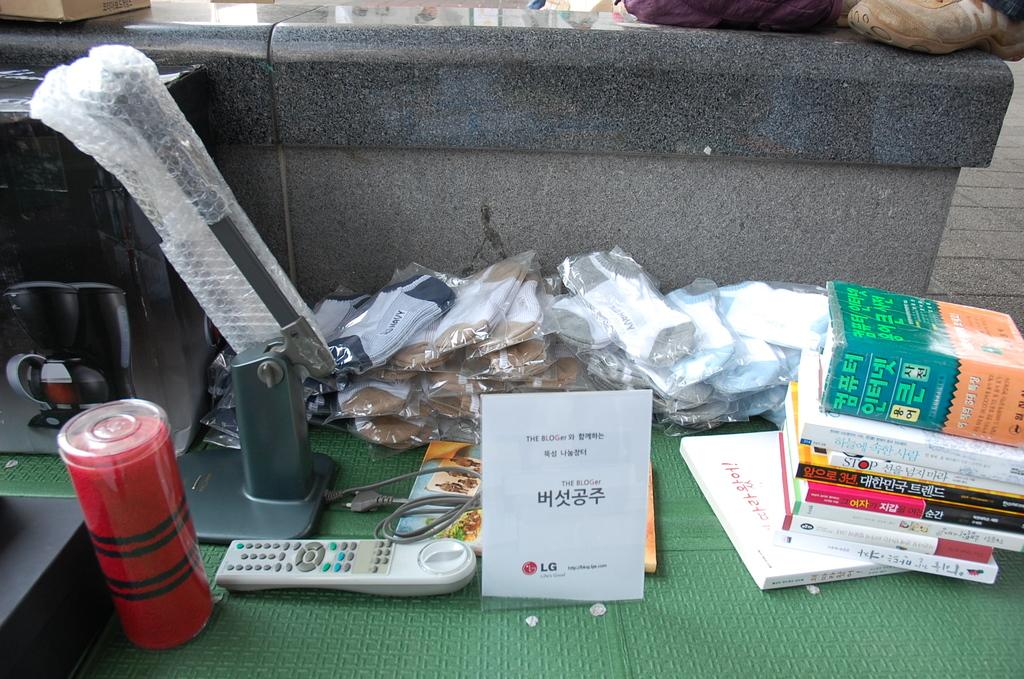<image>
Present a compact description of the photo's key features. Al LG pamphlet is next to a remote and has books stacked on the other side. 